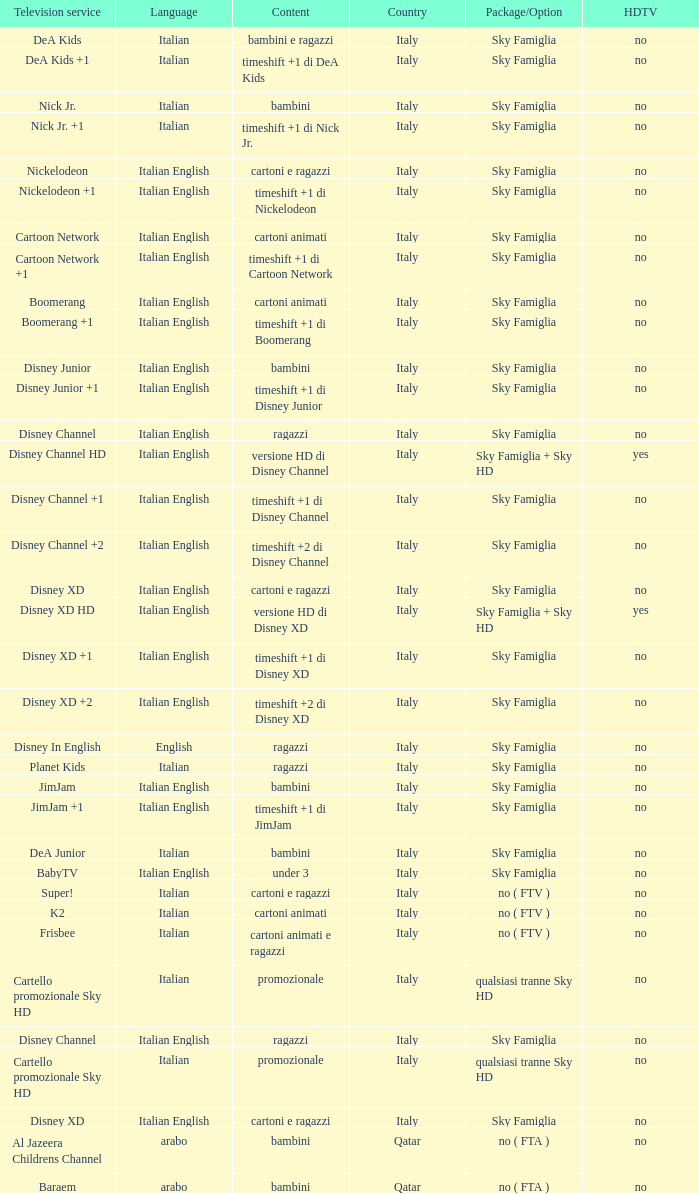What is the HDTV when the Package/Option is sky famiglia, and a Television service of boomerang +1? No. 